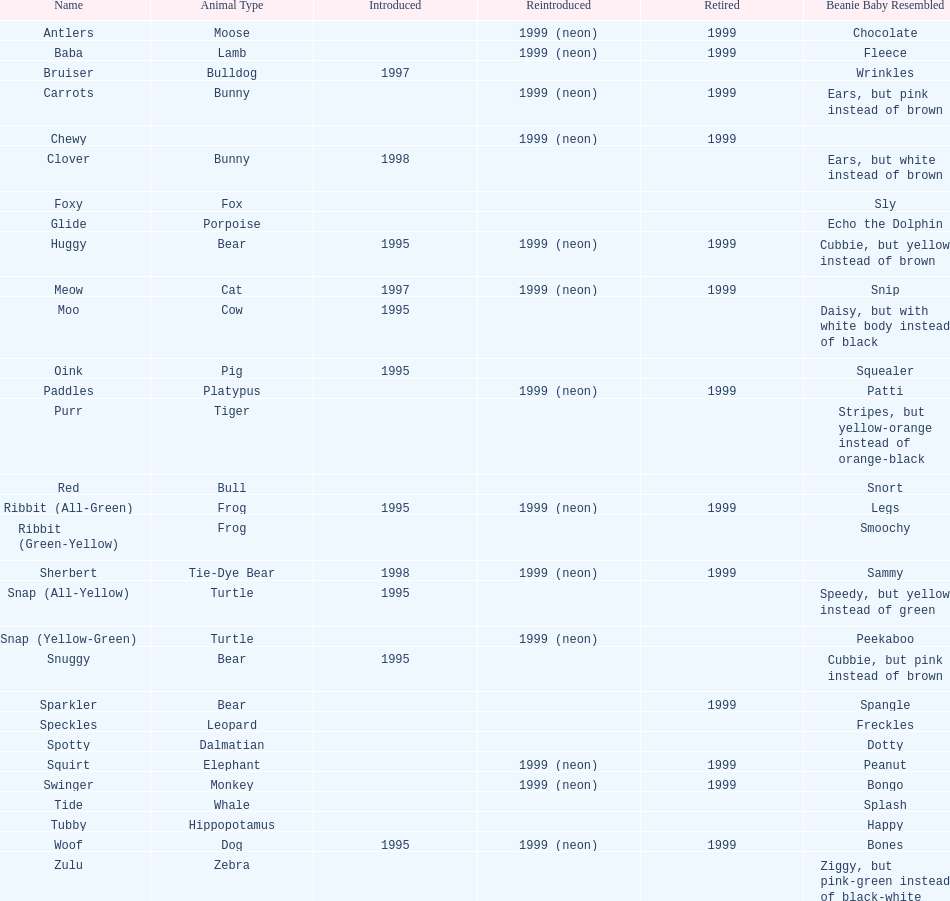What is the name of the pillow pal that comes after clover? Foxy. 